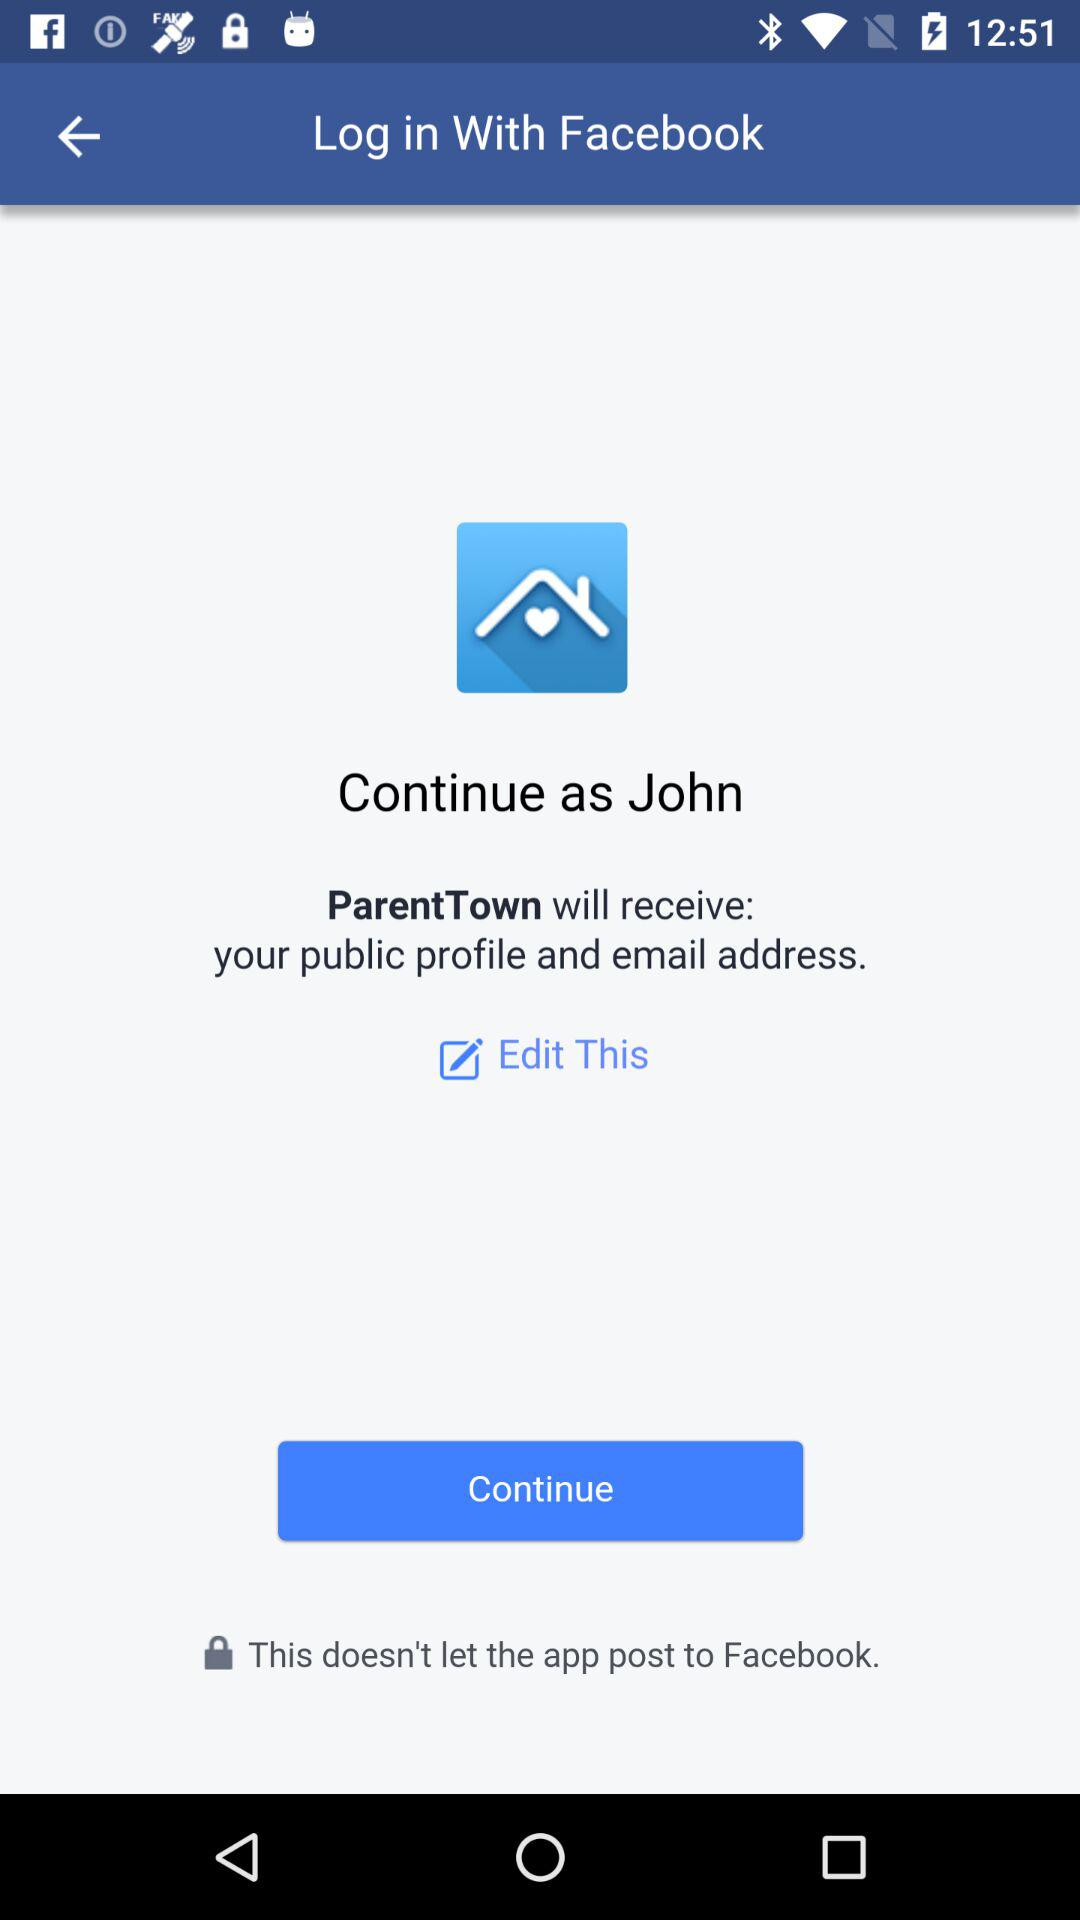What is the username? The username is John. 